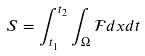Convert formula to latex. <formula><loc_0><loc_0><loc_500><loc_500>S = \int _ { t _ { 1 } } ^ { t _ { 2 } } \int _ { \Omega } \mathcal { F } d x d t</formula> 